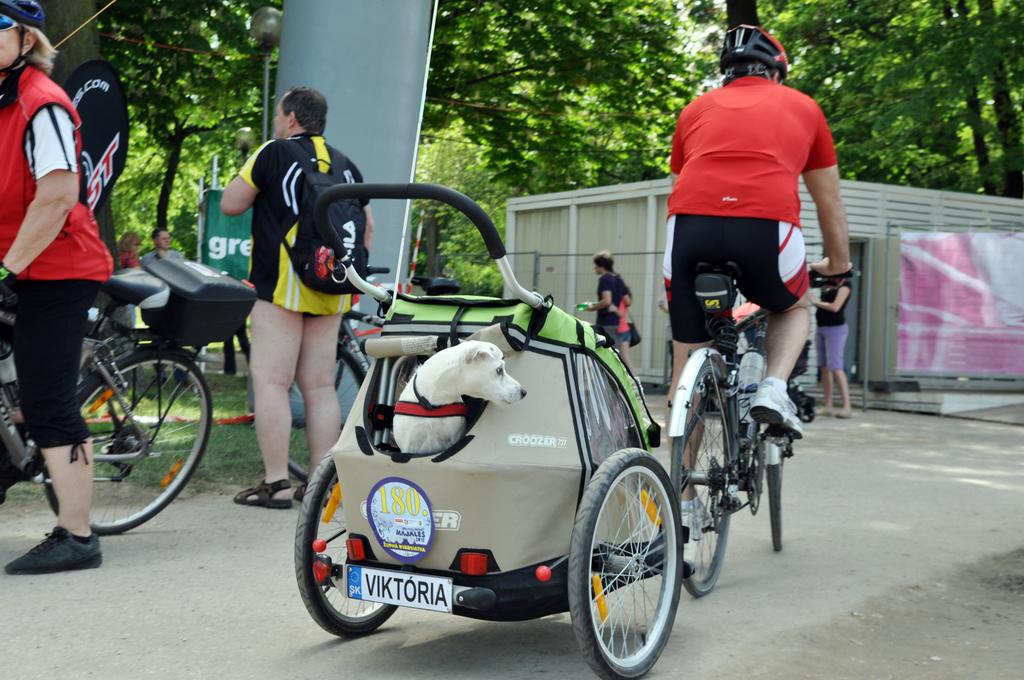How many people are in the group visible in the image? There is a group of people in the image, but the exact number cannot be determined from the provided facts. What is the person on the road doing? The person is riding a bicycle on the road. What type of animal is present in the image? There is a dog in the image. What items can be seen in the image that might be used for carrying or storing things? There are bags, a box, and a shed in the image. What type of signage is present in the image? There are banners in the image. What can be seen in the background of the image? Trees are visible in the background of the image. Can you tell me how many nuts are floating in the ocean in the image? There is no ocean or nuts present in the image. What type of activity are the people engaged in while riding the bicycle in the image? The provided facts do not mention any specific activity that the person riding the bicycle is engaged in. 